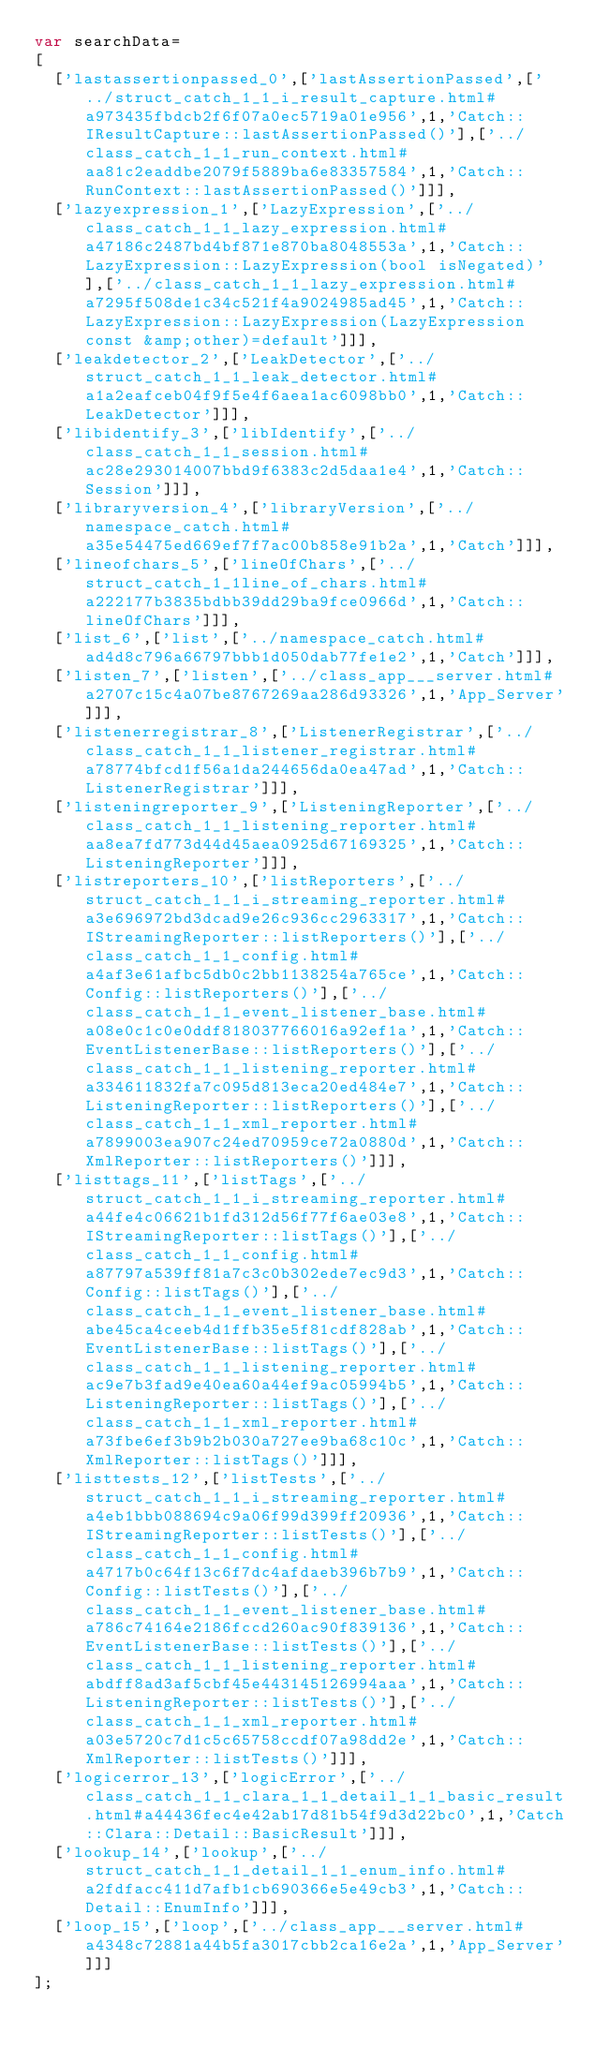Convert code to text. <code><loc_0><loc_0><loc_500><loc_500><_JavaScript_>var searchData=
[
  ['lastassertionpassed_0',['lastAssertionPassed',['../struct_catch_1_1_i_result_capture.html#a973435fbdcb2f6f07a0ec5719a01e956',1,'Catch::IResultCapture::lastAssertionPassed()'],['../class_catch_1_1_run_context.html#aa81c2eaddbe2079f5889ba6e83357584',1,'Catch::RunContext::lastAssertionPassed()']]],
  ['lazyexpression_1',['LazyExpression',['../class_catch_1_1_lazy_expression.html#a47186c2487bd4bf871e870ba8048553a',1,'Catch::LazyExpression::LazyExpression(bool isNegated)'],['../class_catch_1_1_lazy_expression.html#a7295f508de1c34c521f4a9024985ad45',1,'Catch::LazyExpression::LazyExpression(LazyExpression const &amp;other)=default']]],
  ['leakdetector_2',['LeakDetector',['../struct_catch_1_1_leak_detector.html#a1a2eafceb04f9f5e4f6aea1ac6098bb0',1,'Catch::LeakDetector']]],
  ['libidentify_3',['libIdentify',['../class_catch_1_1_session.html#ac28e293014007bbd9f6383c2d5daa1e4',1,'Catch::Session']]],
  ['libraryversion_4',['libraryVersion',['../namespace_catch.html#a35e54475ed669ef7f7ac00b858e91b2a',1,'Catch']]],
  ['lineofchars_5',['lineOfChars',['../struct_catch_1_1line_of_chars.html#a222177b3835bdbb39dd29ba9fce0966d',1,'Catch::lineOfChars']]],
  ['list_6',['list',['../namespace_catch.html#ad4d8c796a66797bbb1d050dab77fe1e2',1,'Catch']]],
  ['listen_7',['listen',['../class_app___server.html#a2707c15c4a07be8767269aa286d93326',1,'App_Server']]],
  ['listenerregistrar_8',['ListenerRegistrar',['../class_catch_1_1_listener_registrar.html#a78774bfcd1f56a1da244656da0ea47ad',1,'Catch::ListenerRegistrar']]],
  ['listeningreporter_9',['ListeningReporter',['../class_catch_1_1_listening_reporter.html#aa8ea7fd773d44d45aea0925d67169325',1,'Catch::ListeningReporter']]],
  ['listreporters_10',['listReporters',['../struct_catch_1_1_i_streaming_reporter.html#a3e696972bd3dcad9e26c936cc2963317',1,'Catch::IStreamingReporter::listReporters()'],['../class_catch_1_1_config.html#a4af3e61afbc5db0c2bb1138254a765ce',1,'Catch::Config::listReporters()'],['../class_catch_1_1_event_listener_base.html#a08e0c1c0e0ddf818037766016a92ef1a',1,'Catch::EventListenerBase::listReporters()'],['../class_catch_1_1_listening_reporter.html#a334611832fa7c095d813eca20ed484e7',1,'Catch::ListeningReporter::listReporters()'],['../class_catch_1_1_xml_reporter.html#a7899003ea907c24ed70959ce72a0880d',1,'Catch::XmlReporter::listReporters()']]],
  ['listtags_11',['listTags',['../struct_catch_1_1_i_streaming_reporter.html#a44fe4c06621b1fd312d56f77f6ae03e8',1,'Catch::IStreamingReporter::listTags()'],['../class_catch_1_1_config.html#a87797a539ff81a7c3c0b302ede7ec9d3',1,'Catch::Config::listTags()'],['../class_catch_1_1_event_listener_base.html#abe45ca4ceeb4d1ffb35e5f81cdf828ab',1,'Catch::EventListenerBase::listTags()'],['../class_catch_1_1_listening_reporter.html#ac9e7b3fad9e40ea60a44ef9ac05994b5',1,'Catch::ListeningReporter::listTags()'],['../class_catch_1_1_xml_reporter.html#a73fbe6ef3b9b2b030a727ee9ba68c10c',1,'Catch::XmlReporter::listTags()']]],
  ['listtests_12',['listTests',['../struct_catch_1_1_i_streaming_reporter.html#a4eb1bbb088694c9a06f99d399ff20936',1,'Catch::IStreamingReporter::listTests()'],['../class_catch_1_1_config.html#a4717b0c64f13c6f7dc4afdaeb396b7b9',1,'Catch::Config::listTests()'],['../class_catch_1_1_event_listener_base.html#a786c74164e2186fccd260ac90f839136',1,'Catch::EventListenerBase::listTests()'],['../class_catch_1_1_listening_reporter.html#abdff8ad3af5cbf45e443145126994aaa',1,'Catch::ListeningReporter::listTests()'],['../class_catch_1_1_xml_reporter.html#a03e5720c7d1c5c65758ccdf07a98dd2e',1,'Catch::XmlReporter::listTests()']]],
  ['logicerror_13',['logicError',['../class_catch_1_1_clara_1_1_detail_1_1_basic_result.html#a44436fec4e42ab17d81b54f9d3d22bc0',1,'Catch::Clara::Detail::BasicResult']]],
  ['lookup_14',['lookup',['../struct_catch_1_1_detail_1_1_enum_info.html#a2fdfacc411d7afb1cb690366e5e49cb3',1,'Catch::Detail::EnumInfo']]],
  ['loop_15',['loop',['../class_app___server.html#a4348c72881a44b5fa3017cbb2ca16e2a',1,'App_Server']]]
];
</code> 